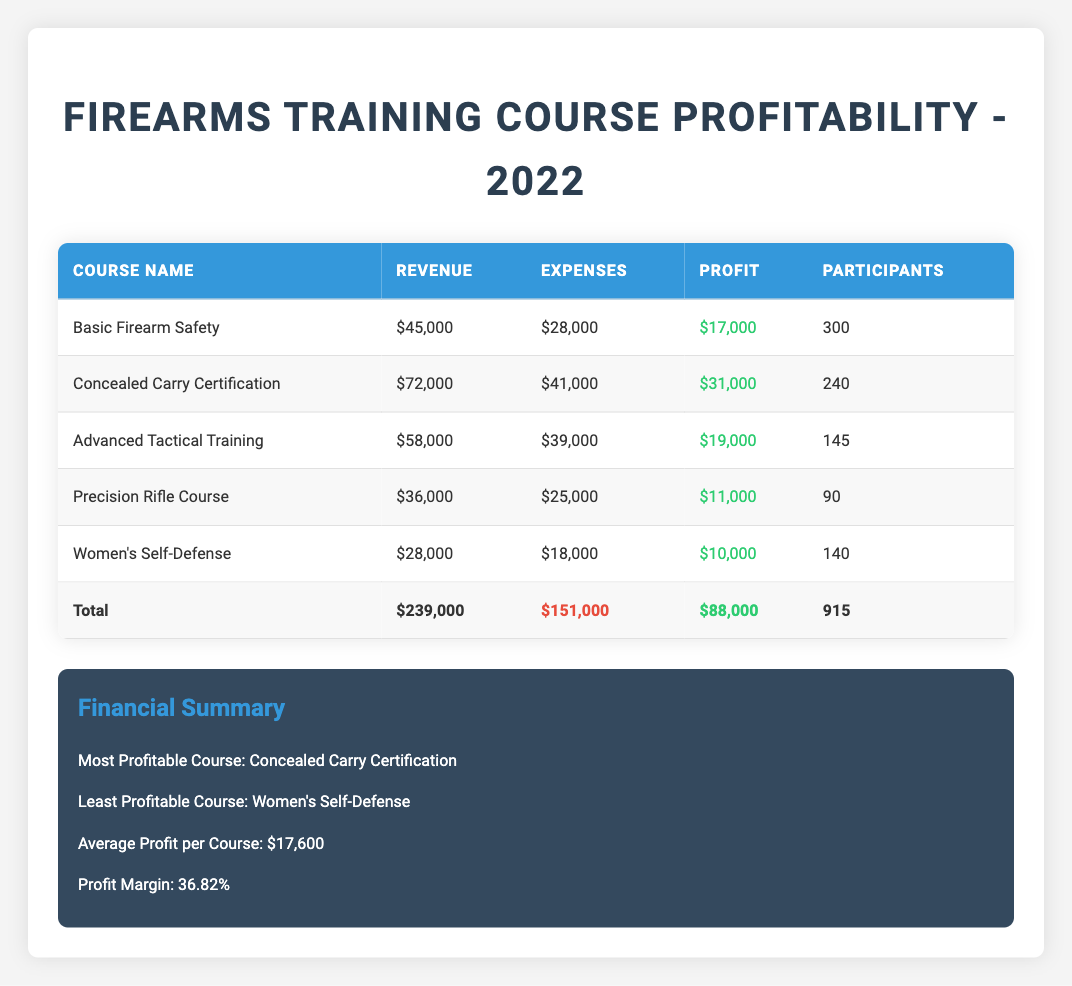What was the revenue for the Advanced Tactical Training course? The revenue is clearly listed in the row for the Advanced Tactical Training course, which is $58,000.
Answer: $58,000 How many total participants attended the firearms training courses? The total number of participants is summarized at the bottom of the table, which states there were 915 participants across all courses.
Answer: 915 What is the profit margin percentage for the courses? The profit margin percentage is provided in the financial summary section; it states that the profit margin is 36.82%.
Answer: 36.82% Which course had the least profit, and how much was it? The least profitable course is indicated in the financial summary section as Women's Self-Defense with a profit of $10,000.
Answer: Women's Self-Defense, $10,000 What is the total profit across all courses? The total profit can be found in the last row of the table, where it totals $88,000 across all firearms training courses.
Answer: $88,000 What was the total revenue for the Basic Firearm Safety course combined with the Precision Rifle Course? The revenue for Basic Firearm Safety is $45,000, and for Precision Rifle Course, it is $36,000; adding the two gives $45,000 + $36,000 = $81,000 for both courses combined.
Answer: $81,000 Is the profit from the Concealed Carry Certification course greater than $30,000? The profit for the Concealed Carry Certification course is stated as $31,000, which is indeed greater than $30,000, so the answer is yes.
Answer: Yes What is the average profit per course based on the total profit and the number of courses offered? The total profit is $88,000, and there are 5 courses. Dividing these gives an average profit of $88,000 / 5 = $17,600 per course.
Answer: $17,600 How many more participants attended the Basic Firearm Safety course compared to the Precision Rifle Course? The Basic Firearm Safety course had 300 participants, while the Precision Rifle Course had 90 participants. The difference is calculated by subtracting: 300 - 90 = 210 more participants in Basic Firearm Safety.
Answer: 210 